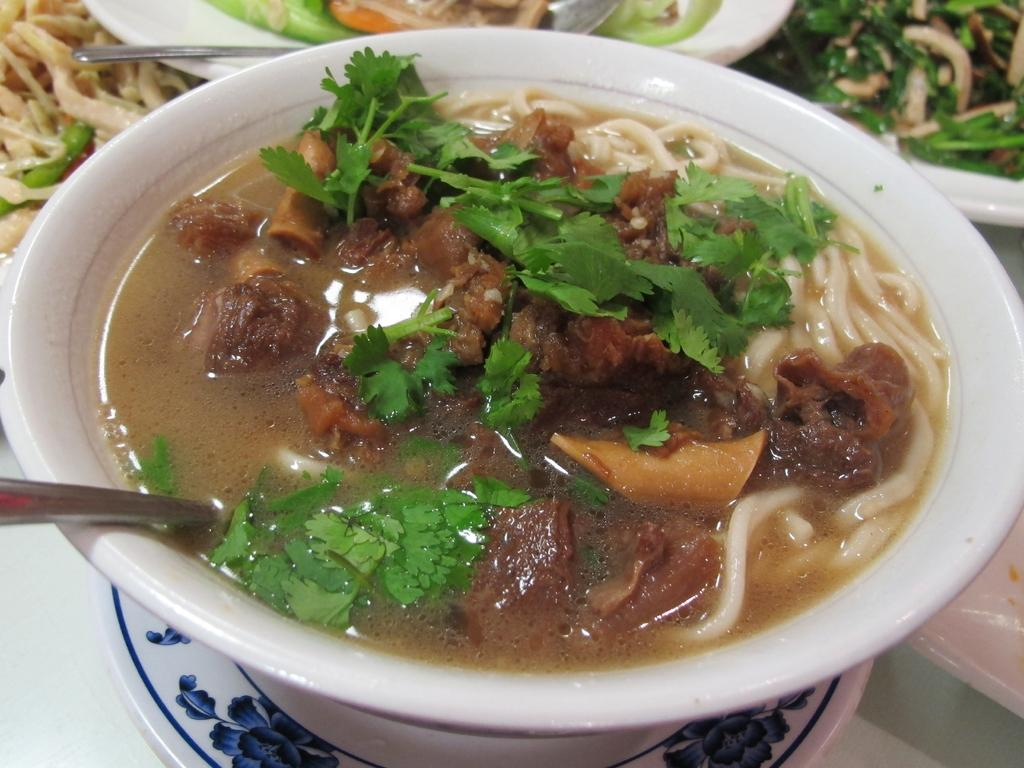What is present in the image? There is a bowl in the image. What is inside the bowl? The bowl is filled with a food item. What type of gold can be seen in the image? There is no gold present in the image; it only contains a bowl filled with a food item. How does the feeling of the food item change throughout the image? The image does not depict any changes in the feeling of the food item, as it is a still image. 